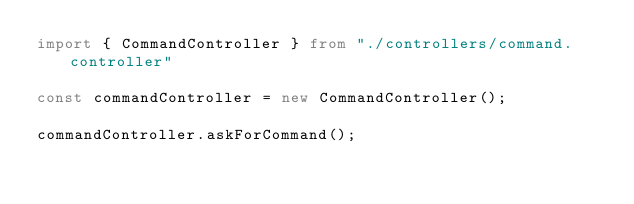Convert code to text. <code><loc_0><loc_0><loc_500><loc_500><_TypeScript_>import { CommandController } from "./controllers/command.controller"

const commandController = new CommandController();

commandController.askForCommand();</code> 